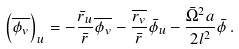Convert formula to latex. <formula><loc_0><loc_0><loc_500><loc_500>\left ( \overline { \phi _ { v } } \right ) _ { u } = - \frac { \bar { r } _ { u } } { \bar { r } } \overline { \phi _ { v } } - \frac { \overline { { r } _ { v } } } { \bar { r } } \bar { \phi } _ { u } - \frac { \bar { \Omega } ^ { 2 } a } { 2 l ^ { 2 } } \bar { \phi } \, .</formula> 